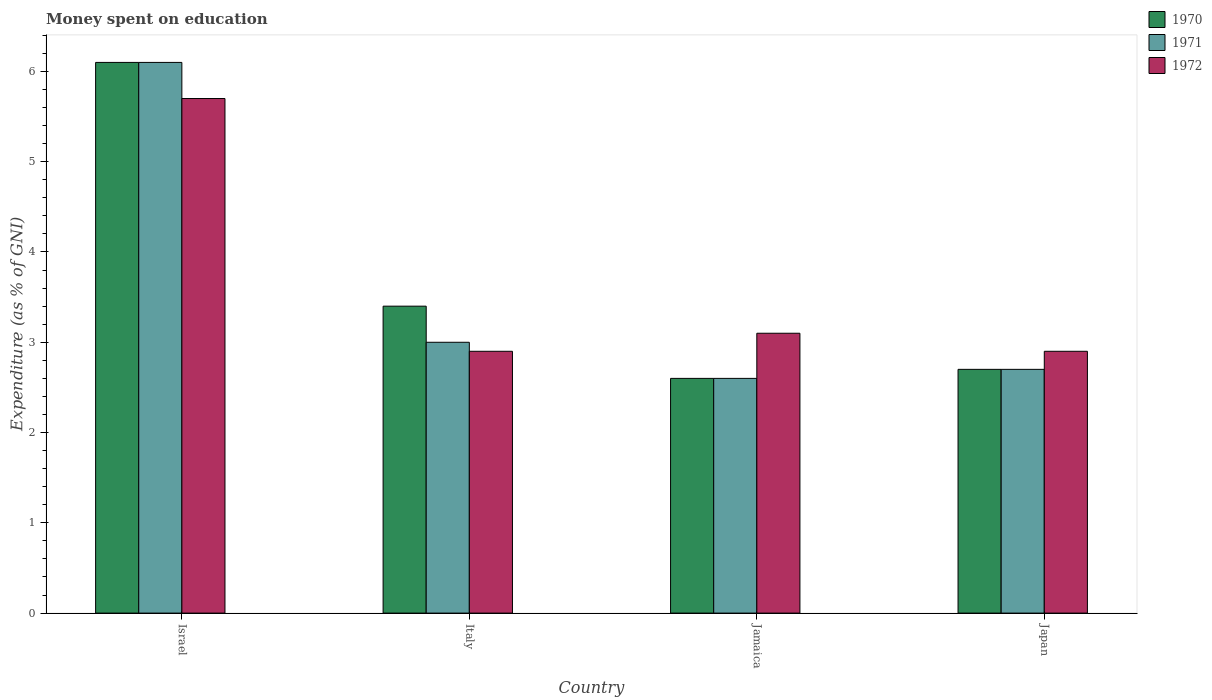How many groups of bars are there?
Provide a short and direct response. 4. Are the number of bars on each tick of the X-axis equal?
Offer a very short reply. Yes. How many bars are there on the 4th tick from the left?
Keep it short and to the point. 3. How many bars are there on the 3rd tick from the right?
Keep it short and to the point. 3. What is the label of the 1st group of bars from the left?
Offer a very short reply. Israel. In how many cases, is the number of bars for a given country not equal to the number of legend labels?
Provide a succinct answer. 0. Across all countries, what is the maximum amount of money spent on education in 1970?
Make the answer very short. 6.1. In which country was the amount of money spent on education in 1972 maximum?
Provide a succinct answer. Israel. What is the total amount of money spent on education in 1971 in the graph?
Provide a succinct answer. 14.4. What is the difference between the amount of money spent on education in 1971 in Italy and the amount of money spent on education in 1970 in Israel?
Your answer should be compact. -3.1. What is the average amount of money spent on education in 1972 per country?
Ensure brevity in your answer.  3.65. What is the difference between the amount of money spent on education of/in 1971 and amount of money spent on education of/in 1970 in Italy?
Make the answer very short. -0.4. In how many countries, is the amount of money spent on education in 1972 greater than 4.8 %?
Ensure brevity in your answer.  1. What is the ratio of the amount of money spent on education in 1972 in Israel to that in Jamaica?
Your answer should be compact. 1.84. Is the amount of money spent on education in 1970 in Israel less than that in Jamaica?
Make the answer very short. No. Is the difference between the amount of money spent on education in 1971 in Israel and Italy greater than the difference between the amount of money spent on education in 1970 in Israel and Italy?
Make the answer very short. Yes. What is the difference between the highest and the second highest amount of money spent on education in 1972?
Offer a very short reply. -0.2. What is the difference between the highest and the lowest amount of money spent on education in 1970?
Make the answer very short. 3.5. In how many countries, is the amount of money spent on education in 1970 greater than the average amount of money spent on education in 1970 taken over all countries?
Provide a short and direct response. 1. What does the 3rd bar from the left in Israel represents?
Keep it short and to the point. 1972. What does the 2nd bar from the right in Japan represents?
Make the answer very short. 1971. Is it the case that in every country, the sum of the amount of money spent on education in 1970 and amount of money spent on education in 1971 is greater than the amount of money spent on education in 1972?
Ensure brevity in your answer.  Yes. How many bars are there?
Make the answer very short. 12. Are the values on the major ticks of Y-axis written in scientific E-notation?
Your response must be concise. No. Does the graph contain any zero values?
Your response must be concise. No. Does the graph contain grids?
Give a very brief answer. No. Where does the legend appear in the graph?
Your response must be concise. Top right. How many legend labels are there?
Offer a terse response. 3. How are the legend labels stacked?
Keep it short and to the point. Vertical. What is the title of the graph?
Your answer should be compact. Money spent on education. Does "1976" appear as one of the legend labels in the graph?
Keep it short and to the point. No. What is the label or title of the X-axis?
Offer a terse response. Country. What is the label or title of the Y-axis?
Provide a short and direct response. Expenditure (as % of GNI). What is the Expenditure (as % of GNI) in 1970 in Israel?
Your answer should be compact. 6.1. What is the Expenditure (as % of GNI) in 1972 in Israel?
Ensure brevity in your answer.  5.7. What is the Expenditure (as % of GNI) in 1970 in Italy?
Your answer should be very brief. 3.4. What is the Expenditure (as % of GNI) in 1971 in Italy?
Provide a short and direct response. 3. What is the Expenditure (as % of GNI) in 1970 in Jamaica?
Provide a short and direct response. 2.6. What is the Expenditure (as % of GNI) in 1971 in Jamaica?
Make the answer very short. 2.6. What is the Expenditure (as % of GNI) of 1972 in Jamaica?
Keep it short and to the point. 3.1. What is the Expenditure (as % of GNI) in 1972 in Japan?
Your response must be concise. 2.9. Across all countries, what is the maximum Expenditure (as % of GNI) in 1972?
Provide a short and direct response. 5.7. Across all countries, what is the minimum Expenditure (as % of GNI) of 1970?
Offer a very short reply. 2.6. Across all countries, what is the minimum Expenditure (as % of GNI) of 1971?
Your answer should be compact. 2.6. Across all countries, what is the minimum Expenditure (as % of GNI) of 1972?
Your answer should be very brief. 2.9. What is the total Expenditure (as % of GNI) of 1971 in the graph?
Give a very brief answer. 14.4. What is the difference between the Expenditure (as % of GNI) of 1970 in Israel and that in Jamaica?
Make the answer very short. 3.5. What is the difference between the Expenditure (as % of GNI) of 1972 in Israel and that in Jamaica?
Make the answer very short. 2.6. What is the difference between the Expenditure (as % of GNI) of 1970 in Israel and that in Japan?
Give a very brief answer. 3.4. What is the difference between the Expenditure (as % of GNI) of 1971 in Israel and that in Japan?
Provide a succinct answer. 3.4. What is the difference between the Expenditure (as % of GNI) of 1970 in Italy and that in Jamaica?
Your answer should be very brief. 0.8. What is the difference between the Expenditure (as % of GNI) of 1971 in Italy and that in Jamaica?
Provide a succinct answer. 0.4. What is the difference between the Expenditure (as % of GNI) of 1972 in Italy and that in Jamaica?
Provide a succinct answer. -0.2. What is the difference between the Expenditure (as % of GNI) of 1970 in Jamaica and that in Japan?
Provide a short and direct response. -0.1. What is the difference between the Expenditure (as % of GNI) of 1970 in Israel and the Expenditure (as % of GNI) of 1971 in Italy?
Keep it short and to the point. 3.1. What is the difference between the Expenditure (as % of GNI) in 1970 in Israel and the Expenditure (as % of GNI) in 1972 in Italy?
Give a very brief answer. 3.2. What is the difference between the Expenditure (as % of GNI) in 1970 in Israel and the Expenditure (as % of GNI) in 1971 in Jamaica?
Your response must be concise. 3.5. What is the difference between the Expenditure (as % of GNI) in 1970 in Israel and the Expenditure (as % of GNI) in 1972 in Jamaica?
Offer a terse response. 3. What is the difference between the Expenditure (as % of GNI) in 1971 in Israel and the Expenditure (as % of GNI) in 1972 in Jamaica?
Your answer should be compact. 3. What is the difference between the Expenditure (as % of GNI) of 1970 in Israel and the Expenditure (as % of GNI) of 1972 in Japan?
Your answer should be very brief. 3.2. What is the difference between the Expenditure (as % of GNI) of 1971 in Israel and the Expenditure (as % of GNI) of 1972 in Japan?
Provide a succinct answer. 3.2. What is the difference between the Expenditure (as % of GNI) of 1970 in Italy and the Expenditure (as % of GNI) of 1971 in Jamaica?
Provide a succinct answer. 0.8. What is the difference between the Expenditure (as % of GNI) of 1971 in Italy and the Expenditure (as % of GNI) of 1972 in Jamaica?
Offer a terse response. -0.1. What is the difference between the Expenditure (as % of GNI) in 1970 in Italy and the Expenditure (as % of GNI) in 1971 in Japan?
Provide a short and direct response. 0.7. What is the difference between the Expenditure (as % of GNI) of 1970 in Italy and the Expenditure (as % of GNI) of 1972 in Japan?
Offer a very short reply. 0.5. What is the difference between the Expenditure (as % of GNI) of 1971 in Italy and the Expenditure (as % of GNI) of 1972 in Japan?
Your answer should be very brief. 0.1. What is the difference between the Expenditure (as % of GNI) in 1970 in Jamaica and the Expenditure (as % of GNI) in 1971 in Japan?
Offer a terse response. -0.1. What is the difference between the Expenditure (as % of GNI) in 1970 in Jamaica and the Expenditure (as % of GNI) in 1972 in Japan?
Ensure brevity in your answer.  -0.3. What is the difference between the Expenditure (as % of GNI) in 1971 in Jamaica and the Expenditure (as % of GNI) in 1972 in Japan?
Make the answer very short. -0.3. What is the average Expenditure (as % of GNI) in 1970 per country?
Your answer should be very brief. 3.7. What is the average Expenditure (as % of GNI) in 1972 per country?
Provide a short and direct response. 3.65. What is the difference between the Expenditure (as % of GNI) in 1971 and Expenditure (as % of GNI) in 1972 in Israel?
Your response must be concise. 0.4. What is the difference between the Expenditure (as % of GNI) of 1970 and Expenditure (as % of GNI) of 1971 in Italy?
Ensure brevity in your answer.  0.4. What is the difference between the Expenditure (as % of GNI) in 1970 and Expenditure (as % of GNI) in 1972 in Italy?
Offer a terse response. 0.5. What is the difference between the Expenditure (as % of GNI) of 1971 and Expenditure (as % of GNI) of 1972 in Italy?
Provide a short and direct response. 0.1. What is the difference between the Expenditure (as % of GNI) in 1970 and Expenditure (as % of GNI) in 1971 in Japan?
Make the answer very short. 0. What is the difference between the Expenditure (as % of GNI) of 1970 and Expenditure (as % of GNI) of 1972 in Japan?
Your response must be concise. -0.2. What is the difference between the Expenditure (as % of GNI) of 1971 and Expenditure (as % of GNI) of 1972 in Japan?
Provide a succinct answer. -0.2. What is the ratio of the Expenditure (as % of GNI) in 1970 in Israel to that in Italy?
Provide a succinct answer. 1.79. What is the ratio of the Expenditure (as % of GNI) of 1971 in Israel to that in Italy?
Keep it short and to the point. 2.03. What is the ratio of the Expenditure (as % of GNI) of 1972 in Israel to that in Italy?
Keep it short and to the point. 1.97. What is the ratio of the Expenditure (as % of GNI) in 1970 in Israel to that in Jamaica?
Your response must be concise. 2.35. What is the ratio of the Expenditure (as % of GNI) in 1971 in Israel to that in Jamaica?
Offer a very short reply. 2.35. What is the ratio of the Expenditure (as % of GNI) of 1972 in Israel to that in Jamaica?
Offer a terse response. 1.84. What is the ratio of the Expenditure (as % of GNI) in 1970 in Israel to that in Japan?
Give a very brief answer. 2.26. What is the ratio of the Expenditure (as % of GNI) in 1971 in Israel to that in Japan?
Provide a short and direct response. 2.26. What is the ratio of the Expenditure (as % of GNI) in 1972 in Israel to that in Japan?
Offer a terse response. 1.97. What is the ratio of the Expenditure (as % of GNI) in 1970 in Italy to that in Jamaica?
Keep it short and to the point. 1.31. What is the ratio of the Expenditure (as % of GNI) of 1971 in Italy to that in Jamaica?
Your response must be concise. 1.15. What is the ratio of the Expenditure (as % of GNI) in 1972 in Italy to that in Jamaica?
Keep it short and to the point. 0.94. What is the ratio of the Expenditure (as % of GNI) in 1970 in Italy to that in Japan?
Your answer should be compact. 1.26. What is the ratio of the Expenditure (as % of GNI) of 1970 in Jamaica to that in Japan?
Your answer should be very brief. 0.96. What is the ratio of the Expenditure (as % of GNI) of 1972 in Jamaica to that in Japan?
Give a very brief answer. 1.07. What is the difference between the highest and the second highest Expenditure (as % of GNI) in 1970?
Keep it short and to the point. 2.7. What is the difference between the highest and the second highest Expenditure (as % of GNI) in 1972?
Provide a short and direct response. 2.6. What is the difference between the highest and the lowest Expenditure (as % of GNI) in 1970?
Provide a succinct answer. 3.5. What is the difference between the highest and the lowest Expenditure (as % of GNI) of 1971?
Provide a short and direct response. 3.5. What is the difference between the highest and the lowest Expenditure (as % of GNI) in 1972?
Keep it short and to the point. 2.8. 